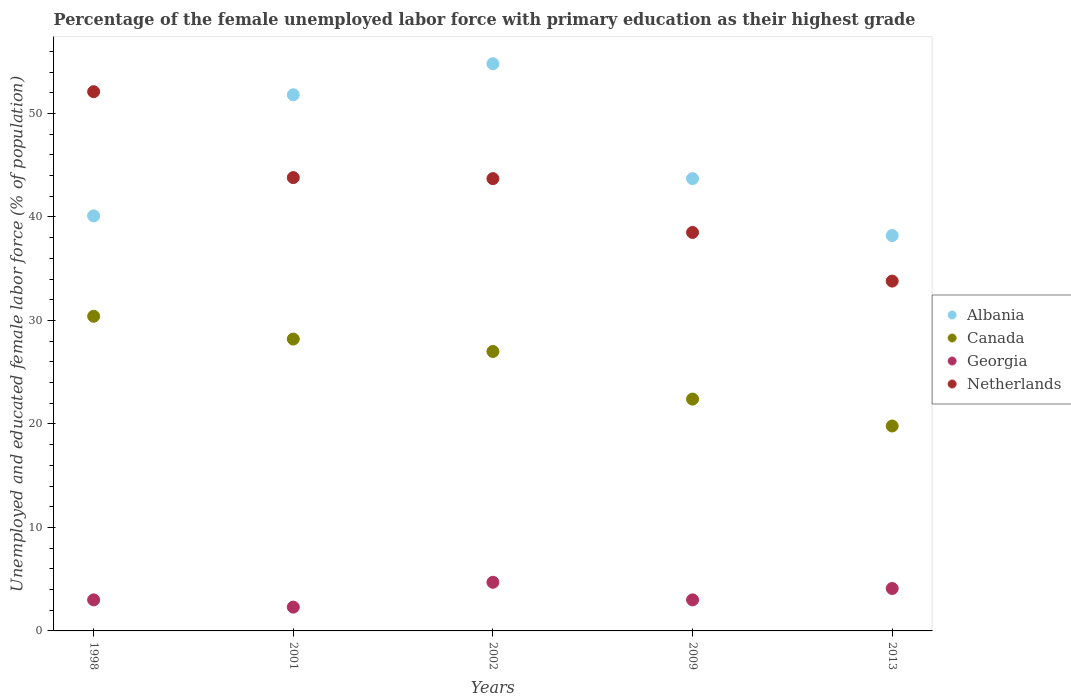Is the number of dotlines equal to the number of legend labels?
Offer a terse response. Yes. What is the percentage of the unemployed female labor force with primary education in Canada in 1998?
Provide a succinct answer. 30.4. Across all years, what is the maximum percentage of the unemployed female labor force with primary education in Canada?
Keep it short and to the point. 30.4. Across all years, what is the minimum percentage of the unemployed female labor force with primary education in Albania?
Offer a terse response. 38.2. In which year was the percentage of the unemployed female labor force with primary education in Albania maximum?
Your response must be concise. 2002. In which year was the percentage of the unemployed female labor force with primary education in Georgia minimum?
Make the answer very short. 2001. What is the total percentage of the unemployed female labor force with primary education in Netherlands in the graph?
Provide a short and direct response. 211.9. What is the difference between the percentage of the unemployed female labor force with primary education in Netherlands in 2001 and that in 2013?
Give a very brief answer. 10. What is the difference between the percentage of the unemployed female labor force with primary education in Netherlands in 1998 and the percentage of the unemployed female labor force with primary education in Albania in 2009?
Give a very brief answer. 8.4. What is the average percentage of the unemployed female labor force with primary education in Canada per year?
Offer a very short reply. 25.56. In the year 2002, what is the difference between the percentage of the unemployed female labor force with primary education in Canada and percentage of the unemployed female labor force with primary education in Albania?
Your answer should be very brief. -27.8. In how many years, is the percentage of the unemployed female labor force with primary education in Georgia greater than 8 %?
Offer a terse response. 0. What is the ratio of the percentage of the unemployed female labor force with primary education in Canada in 1998 to that in 2002?
Your answer should be very brief. 1.13. Is the percentage of the unemployed female labor force with primary education in Canada in 1998 less than that in 2013?
Your answer should be very brief. No. What is the difference between the highest and the second highest percentage of the unemployed female labor force with primary education in Georgia?
Give a very brief answer. 0.6. What is the difference between the highest and the lowest percentage of the unemployed female labor force with primary education in Georgia?
Provide a succinct answer. 2.4. In how many years, is the percentage of the unemployed female labor force with primary education in Albania greater than the average percentage of the unemployed female labor force with primary education in Albania taken over all years?
Provide a short and direct response. 2. Is it the case that in every year, the sum of the percentage of the unemployed female labor force with primary education in Netherlands and percentage of the unemployed female labor force with primary education in Georgia  is greater than the percentage of the unemployed female labor force with primary education in Canada?
Keep it short and to the point. Yes. Does the percentage of the unemployed female labor force with primary education in Netherlands monotonically increase over the years?
Give a very brief answer. No. Is the percentage of the unemployed female labor force with primary education in Albania strictly greater than the percentage of the unemployed female labor force with primary education in Canada over the years?
Make the answer very short. Yes. Is the percentage of the unemployed female labor force with primary education in Albania strictly less than the percentage of the unemployed female labor force with primary education in Georgia over the years?
Give a very brief answer. No. How many dotlines are there?
Offer a very short reply. 4. What is the difference between two consecutive major ticks on the Y-axis?
Your answer should be very brief. 10. Are the values on the major ticks of Y-axis written in scientific E-notation?
Provide a succinct answer. No. Does the graph contain any zero values?
Offer a terse response. No. Where does the legend appear in the graph?
Your response must be concise. Center right. How many legend labels are there?
Your answer should be very brief. 4. How are the legend labels stacked?
Provide a succinct answer. Vertical. What is the title of the graph?
Your answer should be compact. Percentage of the female unemployed labor force with primary education as their highest grade. Does "Europe(developing only)" appear as one of the legend labels in the graph?
Keep it short and to the point. No. What is the label or title of the X-axis?
Your response must be concise. Years. What is the label or title of the Y-axis?
Offer a terse response. Unemployed and educated female labor force (% of population). What is the Unemployed and educated female labor force (% of population) of Albania in 1998?
Offer a very short reply. 40.1. What is the Unemployed and educated female labor force (% of population) in Canada in 1998?
Offer a very short reply. 30.4. What is the Unemployed and educated female labor force (% of population) of Netherlands in 1998?
Your answer should be very brief. 52.1. What is the Unemployed and educated female labor force (% of population) of Albania in 2001?
Make the answer very short. 51.8. What is the Unemployed and educated female labor force (% of population) in Canada in 2001?
Your answer should be compact. 28.2. What is the Unemployed and educated female labor force (% of population) in Georgia in 2001?
Keep it short and to the point. 2.3. What is the Unemployed and educated female labor force (% of population) of Netherlands in 2001?
Your response must be concise. 43.8. What is the Unemployed and educated female labor force (% of population) in Albania in 2002?
Make the answer very short. 54.8. What is the Unemployed and educated female labor force (% of population) in Canada in 2002?
Your answer should be very brief. 27. What is the Unemployed and educated female labor force (% of population) of Georgia in 2002?
Your answer should be very brief. 4.7. What is the Unemployed and educated female labor force (% of population) of Netherlands in 2002?
Your answer should be compact. 43.7. What is the Unemployed and educated female labor force (% of population) in Albania in 2009?
Offer a terse response. 43.7. What is the Unemployed and educated female labor force (% of population) of Canada in 2009?
Provide a short and direct response. 22.4. What is the Unemployed and educated female labor force (% of population) of Netherlands in 2009?
Your response must be concise. 38.5. What is the Unemployed and educated female labor force (% of population) of Albania in 2013?
Ensure brevity in your answer.  38.2. What is the Unemployed and educated female labor force (% of population) in Canada in 2013?
Provide a succinct answer. 19.8. What is the Unemployed and educated female labor force (% of population) in Georgia in 2013?
Your answer should be very brief. 4.1. What is the Unemployed and educated female labor force (% of population) in Netherlands in 2013?
Ensure brevity in your answer.  33.8. Across all years, what is the maximum Unemployed and educated female labor force (% of population) in Albania?
Provide a short and direct response. 54.8. Across all years, what is the maximum Unemployed and educated female labor force (% of population) of Canada?
Provide a succinct answer. 30.4. Across all years, what is the maximum Unemployed and educated female labor force (% of population) in Georgia?
Your response must be concise. 4.7. Across all years, what is the maximum Unemployed and educated female labor force (% of population) of Netherlands?
Offer a very short reply. 52.1. Across all years, what is the minimum Unemployed and educated female labor force (% of population) in Albania?
Give a very brief answer. 38.2. Across all years, what is the minimum Unemployed and educated female labor force (% of population) in Canada?
Make the answer very short. 19.8. Across all years, what is the minimum Unemployed and educated female labor force (% of population) in Georgia?
Your answer should be compact. 2.3. Across all years, what is the minimum Unemployed and educated female labor force (% of population) of Netherlands?
Your answer should be very brief. 33.8. What is the total Unemployed and educated female labor force (% of population) of Albania in the graph?
Offer a terse response. 228.6. What is the total Unemployed and educated female labor force (% of population) of Canada in the graph?
Offer a terse response. 127.8. What is the total Unemployed and educated female labor force (% of population) of Georgia in the graph?
Your answer should be compact. 17.1. What is the total Unemployed and educated female labor force (% of population) in Netherlands in the graph?
Your answer should be compact. 211.9. What is the difference between the Unemployed and educated female labor force (% of population) of Georgia in 1998 and that in 2001?
Give a very brief answer. 0.7. What is the difference between the Unemployed and educated female labor force (% of population) in Albania in 1998 and that in 2002?
Keep it short and to the point. -14.7. What is the difference between the Unemployed and educated female labor force (% of population) in Georgia in 1998 and that in 2002?
Keep it short and to the point. -1.7. What is the difference between the Unemployed and educated female labor force (% of population) of Netherlands in 1998 and that in 2002?
Keep it short and to the point. 8.4. What is the difference between the Unemployed and educated female labor force (% of population) of Canada in 1998 and that in 2009?
Give a very brief answer. 8. What is the difference between the Unemployed and educated female labor force (% of population) of Canada in 1998 and that in 2013?
Your response must be concise. 10.6. What is the difference between the Unemployed and educated female labor force (% of population) of Georgia in 1998 and that in 2013?
Provide a short and direct response. -1.1. What is the difference between the Unemployed and educated female labor force (% of population) in Netherlands in 1998 and that in 2013?
Make the answer very short. 18.3. What is the difference between the Unemployed and educated female labor force (% of population) in Albania in 2001 and that in 2002?
Your answer should be very brief. -3. What is the difference between the Unemployed and educated female labor force (% of population) of Canada in 2001 and that in 2002?
Provide a succinct answer. 1.2. What is the difference between the Unemployed and educated female labor force (% of population) of Albania in 2001 and that in 2009?
Offer a very short reply. 8.1. What is the difference between the Unemployed and educated female labor force (% of population) in Netherlands in 2001 and that in 2009?
Make the answer very short. 5.3. What is the difference between the Unemployed and educated female labor force (% of population) in Albania in 2001 and that in 2013?
Give a very brief answer. 13.6. What is the difference between the Unemployed and educated female labor force (% of population) of Canada in 2001 and that in 2013?
Your answer should be compact. 8.4. What is the difference between the Unemployed and educated female labor force (% of population) in Georgia in 2001 and that in 2013?
Make the answer very short. -1.8. What is the difference between the Unemployed and educated female labor force (% of population) of Netherlands in 2001 and that in 2013?
Give a very brief answer. 10. What is the difference between the Unemployed and educated female labor force (% of population) in Canada in 2002 and that in 2009?
Give a very brief answer. 4.6. What is the difference between the Unemployed and educated female labor force (% of population) of Netherlands in 2002 and that in 2009?
Provide a succinct answer. 5.2. What is the difference between the Unemployed and educated female labor force (% of population) of Georgia in 2002 and that in 2013?
Offer a very short reply. 0.6. What is the difference between the Unemployed and educated female labor force (% of population) in Albania in 2009 and that in 2013?
Ensure brevity in your answer.  5.5. What is the difference between the Unemployed and educated female labor force (% of population) of Canada in 2009 and that in 2013?
Your response must be concise. 2.6. What is the difference between the Unemployed and educated female labor force (% of population) of Albania in 1998 and the Unemployed and educated female labor force (% of population) of Canada in 2001?
Keep it short and to the point. 11.9. What is the difference between the Unemployed and educated female labor force (% of population) of Albania in 1998 and the Unemployed and educated female labor force (% of population) of Georgia in 2001?
Your answer should be compact. 37.8. What is the difference between the Unemployed and educated female labor force (% of population) in Albania in 1998 and the Unemployed and educated female labor force (% of population) in Netherlands in 2001?
Offer a very short reply. -3.7. What is the difference between the Unemployed and educated female labor force (% of population) in Canada in 1998 and the Unemployed and educated female labor force (% of population) in Georgia in 2001?
Offer a terse response. 28.1. What is the difference between the Unemployed and educated female labor force (% of population) in Canada in 1998 and the Unemployed and educated female labor force (% of population) in Netherlands in 2001?
Offer a very short reply. -13.4. What is the difference between the Unemployed and educated female labor force (% of population) of Georgia in 1998 and the Unemployed and educated female labor force (% of population) of Netherlands in 2001?
Make the answer very short. -40.8. What is the difference between the Unemployed and educated female labor force (% of population) of Albania in 1998 and the Unemployed and educated female labor force (% of population) of Georgia in 2002?
Your response must be concise. 35.4. What is the difference between the Unemployed and educated female labor force (% of population) in Canada in 1998 and the Unemployed and educated female labor force (% of population) in Georgia in 2002?
Provide a short and direct response. 25.7. What is the difference between the Unemployed and educated female labor force (% of population) in Canada in 1998 and the Unemployed and educated female labor force (% of population) in Netherlands in 2002?
Give a very brief answer. -13.3. What is the difference between the Unemployed and educated female labor force (% of population) in Georgia in 1998 and the Unemployed and educated female labor force (% of population) in Netherlands in 2002?
Your response must be concise. -40.7. What is the difference between the Unemployed and educated female labor force (% of population) of Albania in 1998 and the Unemployed and educated female labor force (% of population) of Canada in 2009?
Ensure brevity in your answer.  17.7. What is the difference between the Unemployed and educated female labor force (% of population) in Albania in 1998 and the Unemployed and educated female labor force (% of population) in Georgia in 2009?
Keep it short and to the point. 37.1. What is the difference between the Unemployed and educated female labor force (% of population) of Albania in 1998 and the Unemployed and educated female labor force (% of population) of Netherlands in 2009?
Provide a succinct answer. 1.6. What is the difference between the Unemployed and educated female labor force (% of population) in Canada in 1998 and the Unemployed and educated female labor force (% of population) in Georgia in 2009?
Give a very brief answer. 27.4. What is the difference between the Unemployed and educated female labor force (% of population) of Canada in 1998 and the Unemployed and educated female labor force (% of population) of Netherlands in 2009?
Offer a very short reply. -8.1. What is the difference between the Unemployed and educated female labor force (% of population) of Georgia in 1998 and the Unemployed and educated female labor force (% of population) of Netherlands in 2009?
Ensure brevity in your answer.  -35.5. What is the difference between the Unemployed and educated female labor force (% of population) in Albania in 1998 and the Unemployed and educated female labor force (% of population) in Canada in 2013?
Make the answer very short. 20.3. What is the difference between the Unemployed and educated female labor force (% of population) in Canada in 1998 and the Unemployed and educated female labor force (% of population) in Georgia in 2013?
Offer a terse response. 26.3. What is the difference between the Unemployed and educated female labor force (% of population) of Canada in 1998 and the Unemployed and educated female labor force (% of population) of Netherlands in 2013?
Offer a very short reply. -3.4. What is the difference between the Unemployed and educated female labor force (% of population) of Georgia in 1998 and the Unemployed and educated female labor force (% of population) of Netherlands in 2013?
Provide a short and direct response. -30.8. What is the difference between the Unemployed and educated female labor force (% of population) in Albania in 2001 and the Unemployed and educated female labor force (% of population) in Canada in 2002?
Your response must be concise. 24.8. What is the difference between the Unemployed and educated female labor force (% of population) of Albania in 2001 and the Unemployed and educated female labor force (% of population) of Georgia in 2002?
Provide a short and direct response. 47.1. What is the difference between the Unemployed and educated female labor force (% of population) in Albania in 2001 and the Unemployed and educated female labor force (% of population) in Netherlands in 2002?
Your answer should be very brief. 8.1. What is the difference between the Unemployed and educated female labor force (% of population) of Canada in 2001 and the Unemployed and educated female labor force (% of population) of Netherlands in 2002?
Provide a succinct answer. -15.5. What is the difference between the Unemployed and educated female labor force (% of population) of Georgia in 2001 and the Unemployed and educated female labor force (% of population) of Netherlands in 2002?
Your response must be concise. -41.4. What is the difference between the Unemployed and educated female labor force (% of population) of Albania in 2001 and the Unemployed and educated female labor force (% of population) of Canada in 2009?
Your answer should be compact. 29.4. What is the difference between the Unemployed and educated female labor force (% of population) in Albania in 2001 and the Unemployed and educated female labor force (% of population) in Georgia in 2009?
Your response must be concise. 48.8. What is the difference between the Unemployed and educated female labor force (% of population) of Canada in 2001 and the Unemployed and educated female labor force (% of population) of Georgia in 2009?
Offer a very short reply. 25.2. What is the difference between the Unemployed and educated female labor force (% of population) in Georgia in 2001 and the Unemployed and educated female labor force (% of population) in Netherlands in 2009?
Offer a terse response. -36.2. What is the difference between the Unemployed and educated female labor force (% of population) of Albania in 2001 and the Unemployed and educated female labor force (% of population) of Canada in 2013?
Your answer should be very brief. 32. What is the difference between the Unemployed and educated female labor force (% of population) of Albania in 2001 and the Unemployed and educated female labor force (% of population) of Georgia in 2013?
Make the answer very short. 47.7. What is the difference between the Unemployed and educated female labor force (% of population) in Canada in 2001 and the Unemployed and educated female labor force (% of population) in Georgia in 2013?
Provide a short and direct response. 24.1. What is the difference between the Unemployed and educated female labor force (% of population) in Canada in 2001 and the Unemployed and educated female labor force (% of population) in Netherlands in 2013?
Offer a terse response. -5.6. What is the difference between the Unemployed and educated female labor force (% of population) of Georgia in 2001 and the Unemployed and educated female labor force (% of population) of Netherlands in 2013?
Make the answer very short. -31.5. What is the difference between the Unemployed and educated female labor force (% of population) in Albania in 2002 and the Unemployed and educated female labor force (% of population) in Canada in 2009?
Keep it short and to the point. 32.4. What is the difference between the Unemployed and educated female labor force (% of population) of Albania in 2002 and the Unemployed and educated female labor force (% of population) of Georgia in 2009?
Your response must be concise. 51.8. What is the difference between the Unemployed and educated female labor force (% of population) of Canada in 2002 and the Unemployed and educated female labor force (% of population) of Georgia in 2009?
Give a very brief answer. 24. What is the difference between the Unemployed and educated female labor force (% of population) of Canada in 2002 and the Unemployed and educated female labor force (% of population) of Netherlands in 2009?
Your answer should be very brief. -11.5. What is the difference between the Unemployed and educated female labor force (% of population) of Georgia in 2002 and the Unemployed and educated female labor force (% of population) of Netherlands in 2009?
Your answer should be very brief. -33.8. What is the difference between the Unemployed and educated female labor force (% of population) in Albania in 2002 and the Unemployed and educated female labor force (% of population) in Canada in 2013?
Provide a succinct answer. 35. What is the difference between the Unemployed and educated female labor force (% of population) in Albania in 2002 and the Unemployed and educated female labor force (% of population) in Georgia in 2013?
Keep it short and to the point. 50.7. What is the difference between the Unemployed and educated female labor force (% of population) of Canada in 2002 and the Unemployed and educated female labor force (% of population) of Georgia in 2013?
Offer a terse response. 22.9. What is the difference between the Unemployed and educated female labor force (% of population) in Georgia in 2002 and the Unemployed and educated female labor force (% of population) in Netherlands in 2013?
Offer a terse response. -29.1. What is the difference between the Unemployed and educated female labor force (% of population) of Albania in 2009 and the Unemployed and educated female labor force (% of population) of Canada in 2013?
Your answer should be compact. 23.9. What is the difference between the Unemployed and educated female labor force (% of population) in Albania in 2009 and the Unemployed and educated female labor force (% of population) in Georgia in 2013?
Offer a very short reply. 39.6. What is the difference between the Unemployed and educated female labor force (% of population) of Canada in 2009 and the Unemployed and educated female labor force (% of population) of Georgia in 2013?
Your answer should be compact. 18.3. What is the difference between the Unemployed and educated female labor force (% of population) in Canada in 2009 and the Unemployed and educated female labor force (% of population) in Netherlands in 2013?
Make the answer very short. -11.4. What is the difference between the Unemployed and educated female labor force (% of population) in Georgia in 2009 and the Unemployed and educated female labor force (% of population) in Netherlands in 2013?
Your answer should be very brief. -30.8. What is the average Unemployed and educated female labor force (% of population) in Albania per year?
Keep it short and to the point. 45.72. What is the average Unemployed and educated female labor force (% of population) in Canada per year?
Your response must be concise. 25.56. What is the average Unemployed and educated female labor force (% of population) of Georgia per year?
Ensure brevity in your answer.  3.42. What is the average Unemployed and educated female labor force (% of population) in Netherlands per year?
Your answer should be compact. 42.38. In the year 1998, what is the difference between the Unemployed and educated female labor force (% of population) of Albania and Unemployed and educated female labor force (% of population) of Georgia?
Offer a terse response. 37.1. In the year 1998, what is the difference between the Unemployed and educated female labor force (% of population) in Canada and Unemployed and educated female labor force (% of population) in Georgia?
Make the answer very short. 27.4. In the year 1998, what is the difference between the Unemployed and educated female labor force (% of population) of Canada and Unemployed and educated female labor force (% of population) of Netherlands?
Make the answer very short. -21.7. In the year 1998, what is the difference between the Unemployed and educated female labor force (% of population) in Georgia and Unemployed and educated female labor force (% of population) in Netherlands?
Your answer should be very brief. -49.1. In the year 2001, what is the difference between the Unemployed and educated female labor force (% of population) of Albania and Unemployed and educated female labor force (% of population) of Canada?
Offer a terse response. 23.6. In the year 2001, what is the difference between the Unemployed and educated female labor force (% of population) of Albania and Unemployed and educated female labor force (% of population) of Georgia?
Provide a succinct answer. 49.5. In the year 2001, what is the difference between the Unemployed and educated female labor force (% of population) of Albania and Unemployed and educated female labor force (% of population) of Netherlands?
Offer a terse response. 8. In the year 2001, what is the difference between the Unemployed and educated female labor force (% of population) of Canada and Unemployed and educated female labor force (% of population) of Georgia?
Your answer should be very brief. 25.9. In the year 2001, what is the difference between the Unemployed and educated female labor force (% of population) in Canada and Unemployed and educated female labor force (% of population) in Netherlands?
Make the answer very short. -15.6. In the year 2001, what is the difference between the Unemployed and educated female labor force (% of population) in Georgia and Unemployed and educated female labor force (% of population) in Netherlands?
Ensure brevity in your answer.  -41.5. In the year 2002, what is the difference between the Unemployed and educated female labor force (% of population) of Albania and Unemployed and educated female labor force (% of population) of Canada?
Keep it short and to the point. 27.8. In the year 2002, what is the difference between the Unemployed and educated female labor force (% of population) in Albania and Unemployed and educated female labor force (% of population) in Georgia?
Keep it short and to the point. 50.1. In the year 2002, what is the difference between the Unemployed and educated female labor force (% of population) of Albania and Unemployed and educated female labor force (% of population) of Netherlands?
Offer a terse response. 11.1. In the year 2002, what is the difference between the Unemployed and educated female labor force (% of population) of Canada and Unemployed and educated female labor force (% of population) of Georgia?
Make the answer very short. 22.3. In the year 2002, what is the difference between the Unemployed and educated female labor force (% of population) of Canada and Unemployed and educated female labor force (% of population) of Netherlands?
Provide a succinct answer. -16.7. In the year 2002, what is the difference between the Unemployed and educated female labor force (% of population) in Georgia and Unemployed and educated female labor force (% of population) in Netherlands?
Offer a very short reply. -39. In the year 2009, what is the difference between the Unemployed and educated female labor force (% of population) of Albania and Unemployed and educated female labor force (% of population) of Canada?
Make the answer very short. 21.3. In the year 2009, what is the difference between the Unemployed and educated female labor force (% of population) in Albania and Unemployed and educated female labor force (% of population) in Georgia?
Your answer should be compact. 40.7. In the year 2009, what is the difference between the Unemployed and educated female labor force (% of population) of Canada and Unemployed and educated female labor force (% of population) of Netherlands?
Your response must be concise. -16.1. In the year 2009, what is the difference between the Unemployed and educated female labor force (% of population) in Georgia and Unemployed and educated female labor force (% of population) in Netherlands?
Make the answer very short. -35.5. In the year 2013, what is the difference between the Unemployed and educated female labor force (% of population) of Albania and Unemployed and educated female labor force (% of population) of Canada?
Your answer should be compact. 18.4. In the year 2013, what is the difference between the Unemployed and educated female labor force (% of population) of Albania and Unemployed and educated female labor force (% of population) of Georgia?
Your answer should be compact. 34.1. In the year 2013, what is the difference between the Unemployed and educated female labor force (% of population) of Albania and Unemployed and educated female labor force (% of population) of Netherlands?
Keep it short and to the point. 4.4. In the year 2013, what is the difference between the Unemployed and educated female labor force (% of population) of Canada and Unemployed and educated female labor force (% of population) of Georgia?
Make the answer very short. 15.7. In the year 2013, what is the difference between the Unemployed and educated female labor force (% of population) in Canada and Unemployed and educated female labor force (% of population) in Netherlands?
Give a very brief answer. -14. In the year 2013, what is the difference between the Unemployed and educated female labor force (% of population) of Georgia and Unemployed and educated female labor force (% of population) of Netherlands?
Offer a very short reply. -29.7. What is the ratio of the Unemployed and educated female labor force (% of population) of Albania in 1998 to that in 2001?
Give a very brief answer. 0.77. What is the ratio of the Unemployed and educated female labor force (% of population) in Canada in 1998 to that in 2001?
Your answer should be compact. 1.08. What is the ratio of the Unemployed and educated female labor force (% of population) in Georgia in 1998 to that in 2001?
Keep it short and to the point. 1.3. What is the ratio of the Unemployed and educated female labor force (% of population) of Netherlands in 1998 to that in 2001?
Your answer should be very brief. 1.19. What is the ratio of the Unemployed and educated female labor force (% of population) of Albania in 1998 to that in 2002?
Provide a short and direct response. 0.73. What is the ratio of the Unemployed and educated female labor force (% of population) of Canada in 1998 to that in 2002?
Ensure brevity in your answer.  1.13. What is the ratio of the Unemployed and educated female labor force (% of population) of Georgia in 1998 to that in 2002?
Keep it short and to the point. 0.64. What is the ratio of the Unemployed and educated female labor force (% of population) in Netherlands in 1998 to that in 2002?
Make the answer very short. 1.19. What is the ratio of the Unemployed and educated female labor force (% of population) in Albania in 1998 to that in 2009?
Your response must be concise. 0.92. What is the ratio of the Unemployed and educated female labor force (% of population) in Canada in 1998 to that in 2009?
Your answer should be very brief. 1.36. What is the ratio of the Unemployed and educated female labor force (% of population) of Netherlands in 1998 to that in 2009?
Your answer should be compact. 1.35. What is the ratio of the Unemployed and educated female labor force (% of population) in Albania in 1998 to that in 2013?
Keep it short and to the point. 1.05. What is the ratio of the Unemployed and educated female labor force (% of population) of Canada in 1998 to that in 2013?
Give a very brief answer. 1.54. What is the ratio of the Unemployed and educated female labor force (% of population) in Georgia in 1998 to that in 2013?
Your answer should be compact. 0.73. What is the ratio of the Unemployed and educated female labor force (% of population) of Netherlands in 1998 to that in 2013?
Make the answer very short. 1.54. What is the ratio of the Unemployed and educated female labor force (% of population) of Albania in 2001 to that in 2002?
Provide a short and direct response. 0.95. What is the ratio of the Unemployed and educated female labor force (% of population) in Canada in 2001 to that in 2002?
Offer a terse response. 1.04. What is the ratio of the Unemployed and educated female labor force (% of population) of Georgia in 2001 to that in 2002?
Make the answer very short. 0.49. What is the ratio of the Unemployed and educated female labor force (% of population) of Netherlands in 2001 to that in 2002?
Your answer should be very brief. 1. What is the ratio of the Unemployed and educated female labor force (% of population) of Albania in 2001 to that in 2009?
Your answer should be very brief. 1.19. What is the ratio of the Unemployed and educated female labor force (% of population) in Canada in 2001 to that in 2009?
Your response must be concise. 1.26. What is the ratio of the Unemployed and educated female labor force (% of population) of Georgia in 2001 to that in 2009?
Your response must be concise. 0.77. What is the ratio of the Unemployed and educated female labor force (% of population) of Netherlands in 2001 to that in 2009?
Keep it short and to the point. 1.14. What is the ratio of the Unemployed and educated female labor force (% of population) in Albania in 2001 to that in 2013?
Give a very brief answer. 1.36. What is the ratio of the Unemployed and educated female labor force (% of population) in Canada in 2001 to that in 2013?
Give a very brief answer. 1.42. What is the ratio of the Unemployed and educated female labor force (% of population) of Georgia in 2001 to that in 2013?
Your answer should be very brief. 0.56. What is the ratio of the Unemployed and educated female labor force (% of population) in Netherlands in 2001 to that in 2013?
Your answer should be very brief. 1.3. What is the ratio of the Unemployed and educated female labor force (% of population) in Albania in 2002 to that in 2009?
Provide a short and direct response. 1.25. What is the ratio of the Unemployed and educated female labor force (% of population) in Canada in 2002 to that in 2009?
Provide a short and direct response. 1.21. What is the ratio of the Unemployed and educated female labor force (% of population) of Georgia in 2002 to that in 2009?
Provide a succinct answer. 1.57. What is the ratio of the Unemployed and educated female labor force (% of population) in Netherlands in 2002 to that in 2009?
Your answer should be very brief. 1.14. What is the ratio of the Unemployed and educated female labor force (% of population) in Albania in 2002 to that in 2013?
Provide a succinct answer. 1.43. What is the ratio of the Unemployed and educated female labor force (% of population) of Canada in 2002 to that in 2013?
Your answer should be compact. 1.36. What is the ratio of the Unemployed and educated female labor force (% of population) of Georgia in 2002 to that in 2013?
Keep it short and to the point. 1.15. What is the ratio of the Unemployed and educated female labor force (% of population) of Netherlands in 2002 to that in 2013?
Offer a terse response. 1.29. What is the ratio of the Unemployed and educated female labor force (% of population) in Albania in 2009 to that in 2013?
Provide a short and direct response. 1.14. What is the ratio of the Unemployed and educated female labor force (% of population) in Canada in 2009 to that in 2013?
Give a very brief answer. 1.13. What is the ratio of the Unemployed and educated female labor force (% of population) of Georgia in 2009 to that in 2013?
Your answer should be very brief. 0.73. What is the ratio of the Unemployed and educated female labor force (% of population) of Netherlands in 2009 to that in 2013?
Your response must be concise. 1.14. What is the difference between the highest and the second highest Unemployed and educated female labor force (% of population) in Albania?
Keep it short and to the point. 3. What is the difference between the highest and the second highest Unemployed and educated female labor force (% of population) of Canada?
Make the answer very short. 2.2. What is the difference between the highest and the second highest Unemployed and educated female labor force (% of population) in Georgia?
Give a very brief answer. 0.6. What is the difference between the highest and the lowest Unemployed and educated female labor force (% of population) of Canada?
Ensure brevity in your answer.  10.6. What is the difference between the highest and the lowest Unemployed and educated female labor force (% of population) of Georgia?
Your answer should be compact. 2.4. 